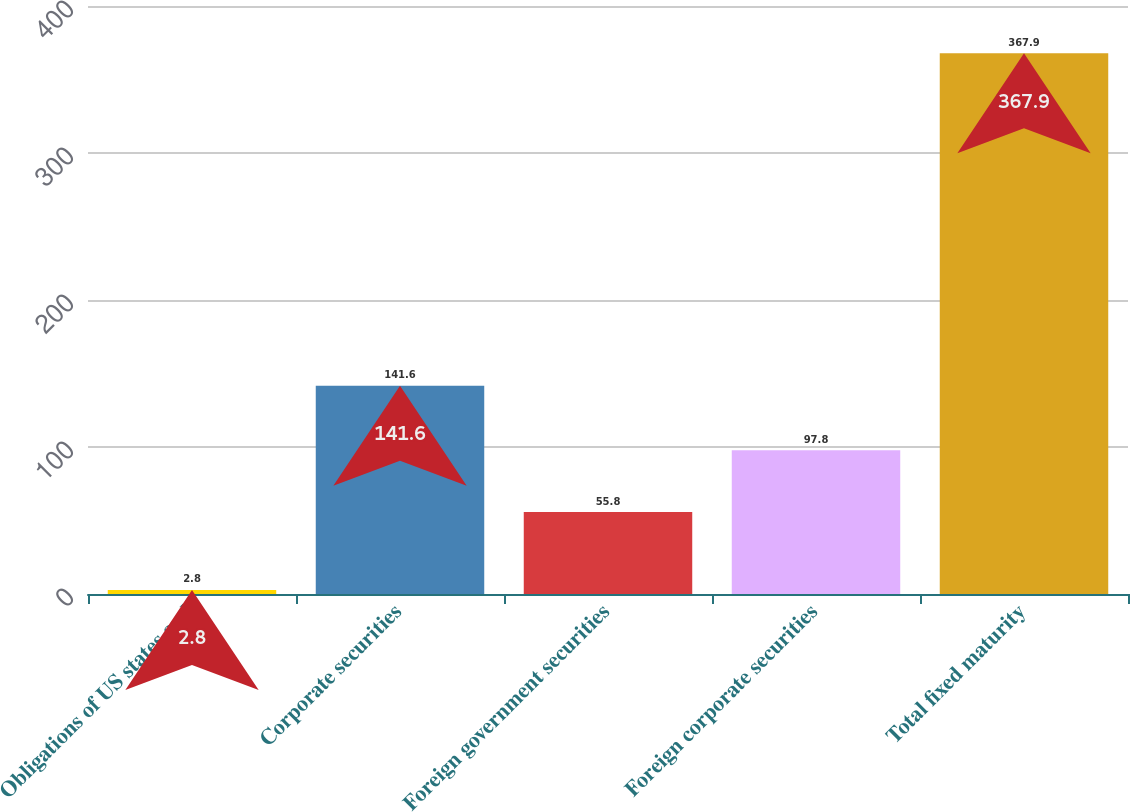Convert chart to OTSL. <chart><loc_0><loc_0><loc_500><loc_500><bar_chart><fcel>Obligations of US states and<fcel>Corporate securities<fcel>Foreign government securities<fcel>Foreign corporate securities<fcel>Total fixed maturity<nl><fcel>2.8<fcel>141.6<fcel>55.8<fcel>97.8<fcel>367.9<nl></chart> 